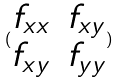Convert formula to latex. <formula><loc_0><loc_0><loc_500><loc_500>( \begin{matrix} f _ { x x } & f _ { x y } \\ f _ { x y } & f _ { y y } \end{matrix} )</formula> 